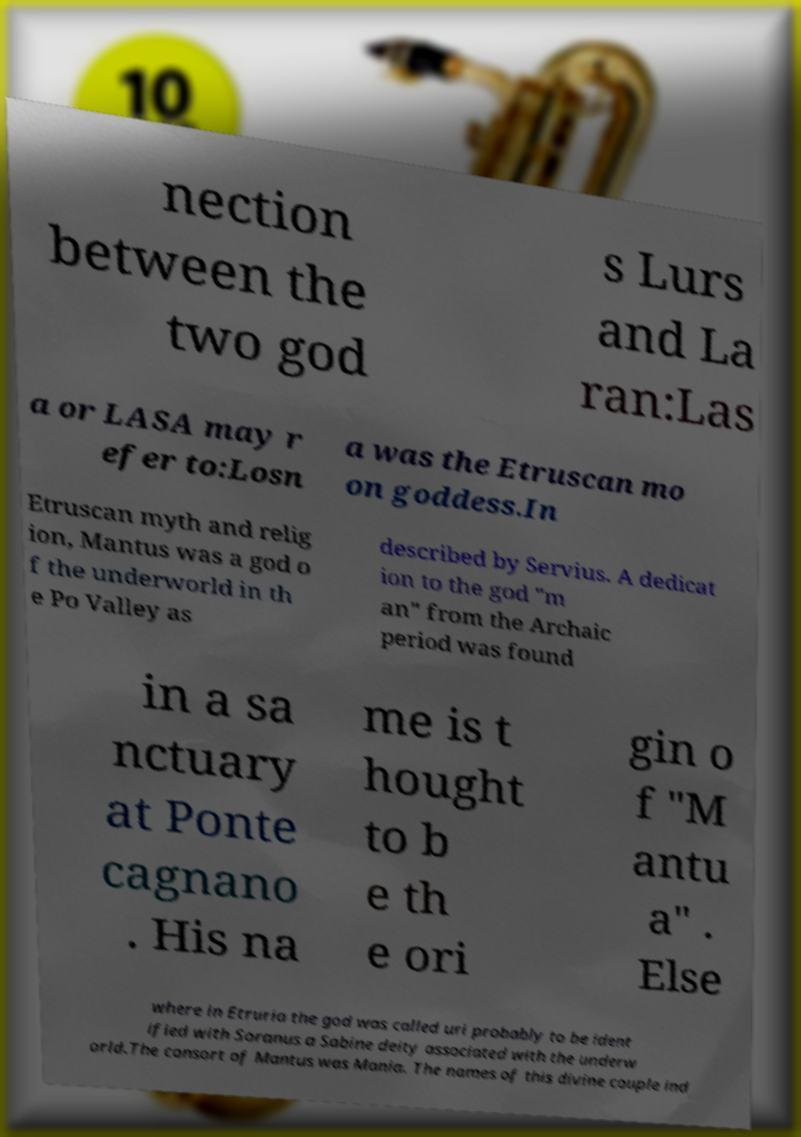I need the written content from this picture converted into text. Can you do that? nection between the two god s Lurs and La ran:Las a or LASA may r efer to:Losn a was the Etruscan mo on goddess.In Etruscan myth and relig ion, Mantus was a god o f the underworld in th e Po Valley as described by Servius. A dedicat ion to the god "m an" from the Archaic period was found in a sa nctuary at Ponte cagnano . His na me is t hought to b e th e ori gin o f "M antu a" . Else where in Etruria the god was called uri probably to be ident ified with Soranus a Sabine deity associated with the underw orld.The consort of Mantus was Mania. The names of this divine couple ind 